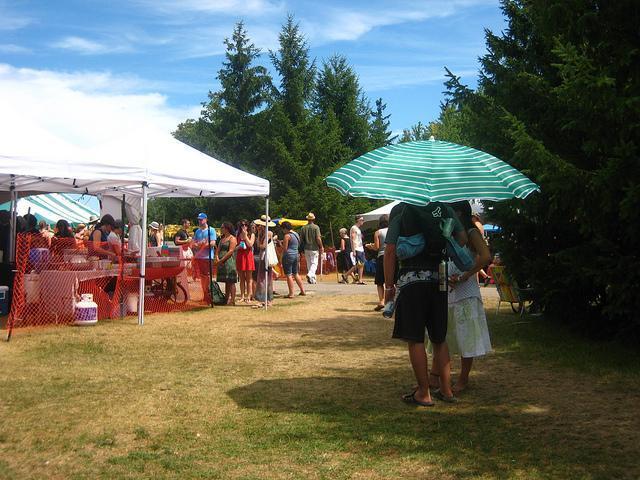How many people are in the photo?
Give a very brief answer. 3. How many zebras can you count?
Give a very brief answer. 0. 